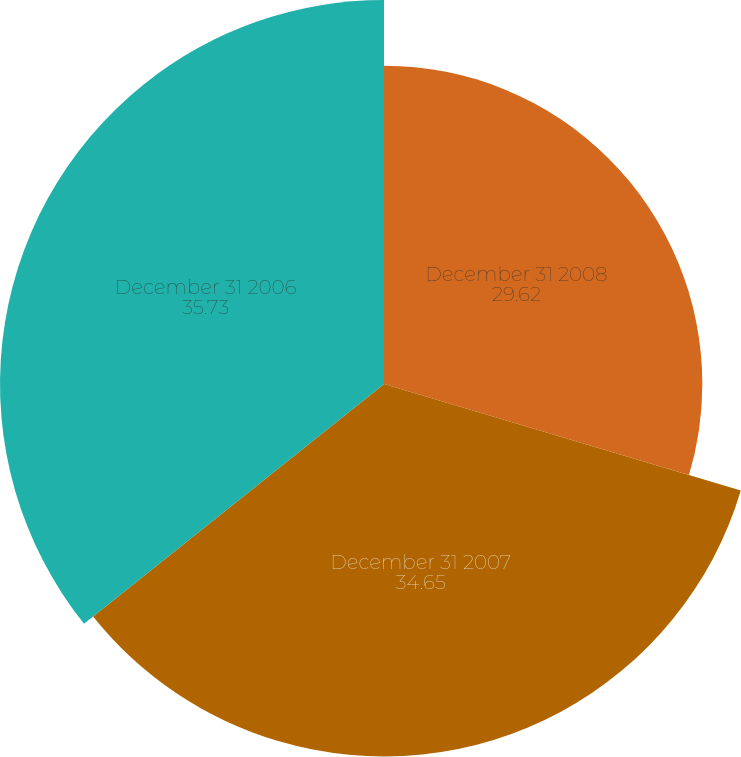Convert chart to OTSL. <chart><loc_0><loc_0><loc_500><loc_500><pie_chart><fcel>December 31 2008<fcel>December 31 2007<fcel>December 31 2006<nl><fcel>29.62%<fcel>34.65%<fcel>35.73%<nl></chart> 